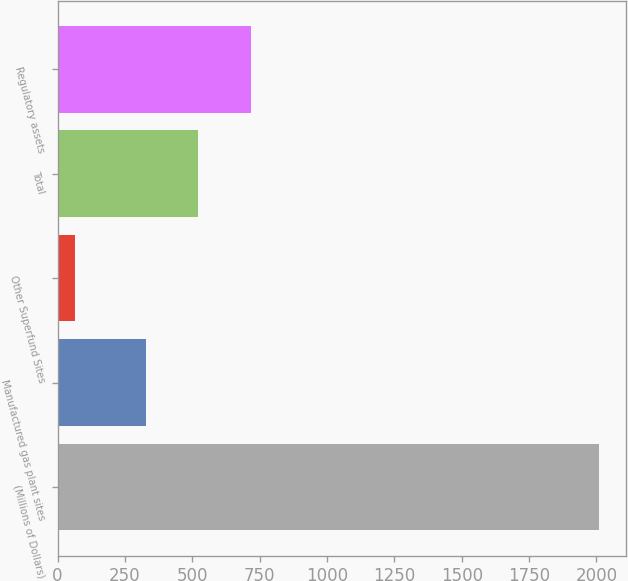Convert chart. <chart><loc_0><loc_0><loc_500><loc_500><bar_chart><fcel>(Millions of Dollars)<fcel>Manufactured gas plant sites<fcel>Other Superfund Sites<fcel>Total<fcel>Regulatory assets<nl><fcel>2010<fcel>327<fcel>65<fcel>521.5<fcel>716<nl></chart> 